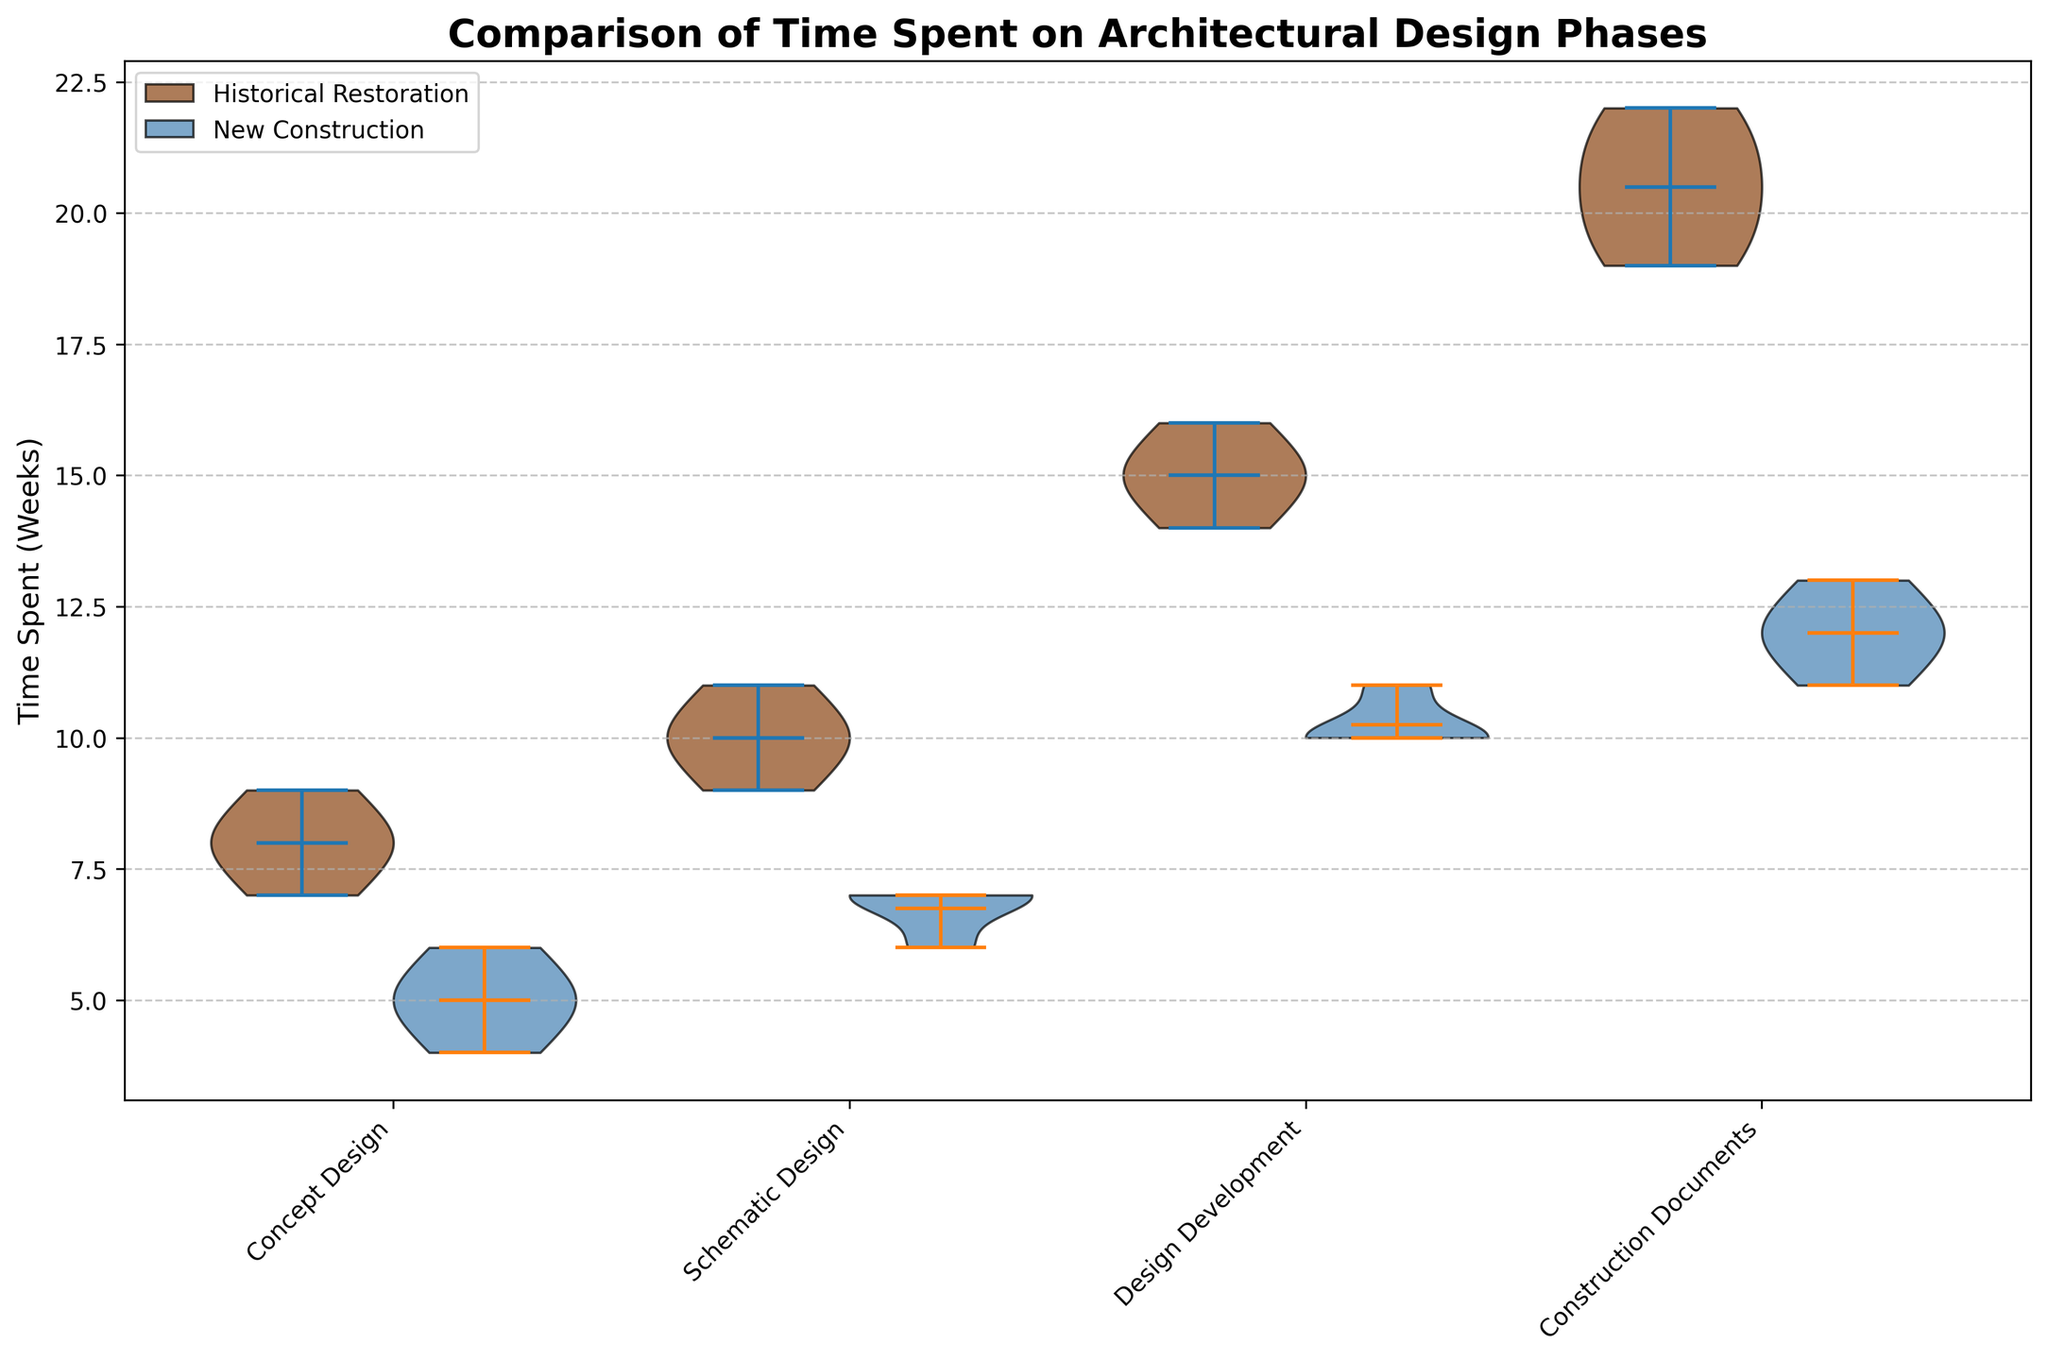What are the four architectural design phases shown on the x-axis? The x-axis has labels for four architectural design phases, which are Concept Design, Schematic Design, Design Development, and Construction Documents.
Answer: Concept Design, Schematic Design, Design Development, Construction Documents Which project type has a generally higher median time spent in the Concept Design phase? The split violin chart shows the medians as horizontal lines inside the violins. The median for Historical Restoration seems to be around 8 weeks, which is higher compared to the New Construction median around 5 weeks.
Answer: Historical Restoration How does the mean time spent in the Construction Documents phase compare between Historical Restoration and New Construction projects? Means are indicated by dots inside the violins. The mean time for Historical Restoration appears around 20-21 weeks, while the mean for New Construction is around 12-13 weeks. Therefore, the mean time for Historical Restoration is significantly higher.
Answer: Historical Restoration is higher What is the general trend observed for time spent moving through the phases for Historical Restoration projects? Looking at the violins for Historical Restoration, the overall time spent seems to increase progressively from Concept Design to Construction Documents. Each subsequent phase shows higher central tendency values and wider distributions.
Answer: Increasing trend Are there any design phases where New Construction projects spend more time than Historical Restoration projects? By comparing the widths and positions of the violins, it is clear that for every phase, Historical Restoration generally takes more time. Hence, New Construction does not exceed Historical Restoration in any phase.
Answer: No What can be observed about the variability in time spent in the Schematic Design phase for both project types? The shape and width of the violins show the variability. The violin for Historical Restoration is wider, suggesting more variability in time spent, while the New Construction violin is narrower, indicating less variability.
Answer: Higher variability in Historical Restoration Which architectural design phase has the largest difference in median time spent between the two project types? By looking at the median lines within the violins, the Construction Documents phase shows the largest difference. Historical Restoration median is around 20 weeks, while New Construction median is around 12 weeks, yielding an 8-week difference.
Answer: Construction Documents What are the colors representing Historical Restoration and New Construction violins, respectively? The violins representing Historical Restoration are colored in a brown shade, while those representing New Construction are in a blue shade.
Answer: Brown, Blue Does the data suggest that one of the project types consistently requires more time across all phases? By comparing both sets of violins across all phases, Historical Restoration consistently has higher central tendency values (means and medians) compared to New Construction.
Answer: Historical Restoration 